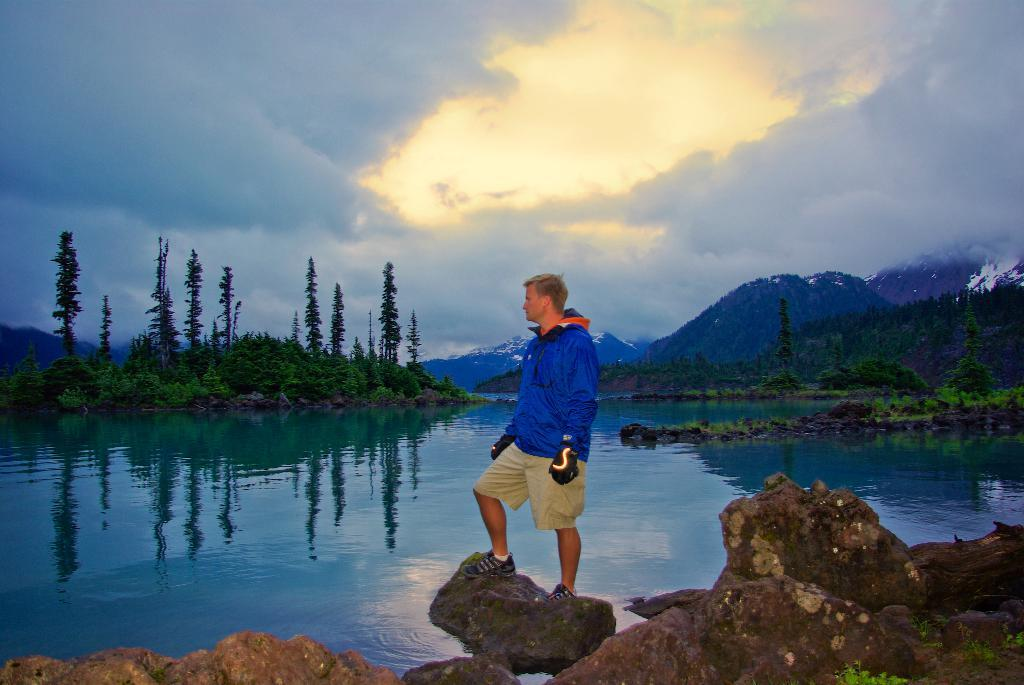What type of natural features can be seen in the image? There are rocks, trees, hills, and water visible in the image. What else is visible in the image besides natural features? There is sky visible in the image, as well as clouds. Is there any human presence in the image? Yes, there is a man in the image. What is the man wearing? The man is wearing a blue jacket. What is the man's position in the image? The man is standing on a stone. Can you hear the kitten crying in the image? There is no kitten or crying sound present in the image. Is there a hospital visible in the image? There is no hospital present in the image. 